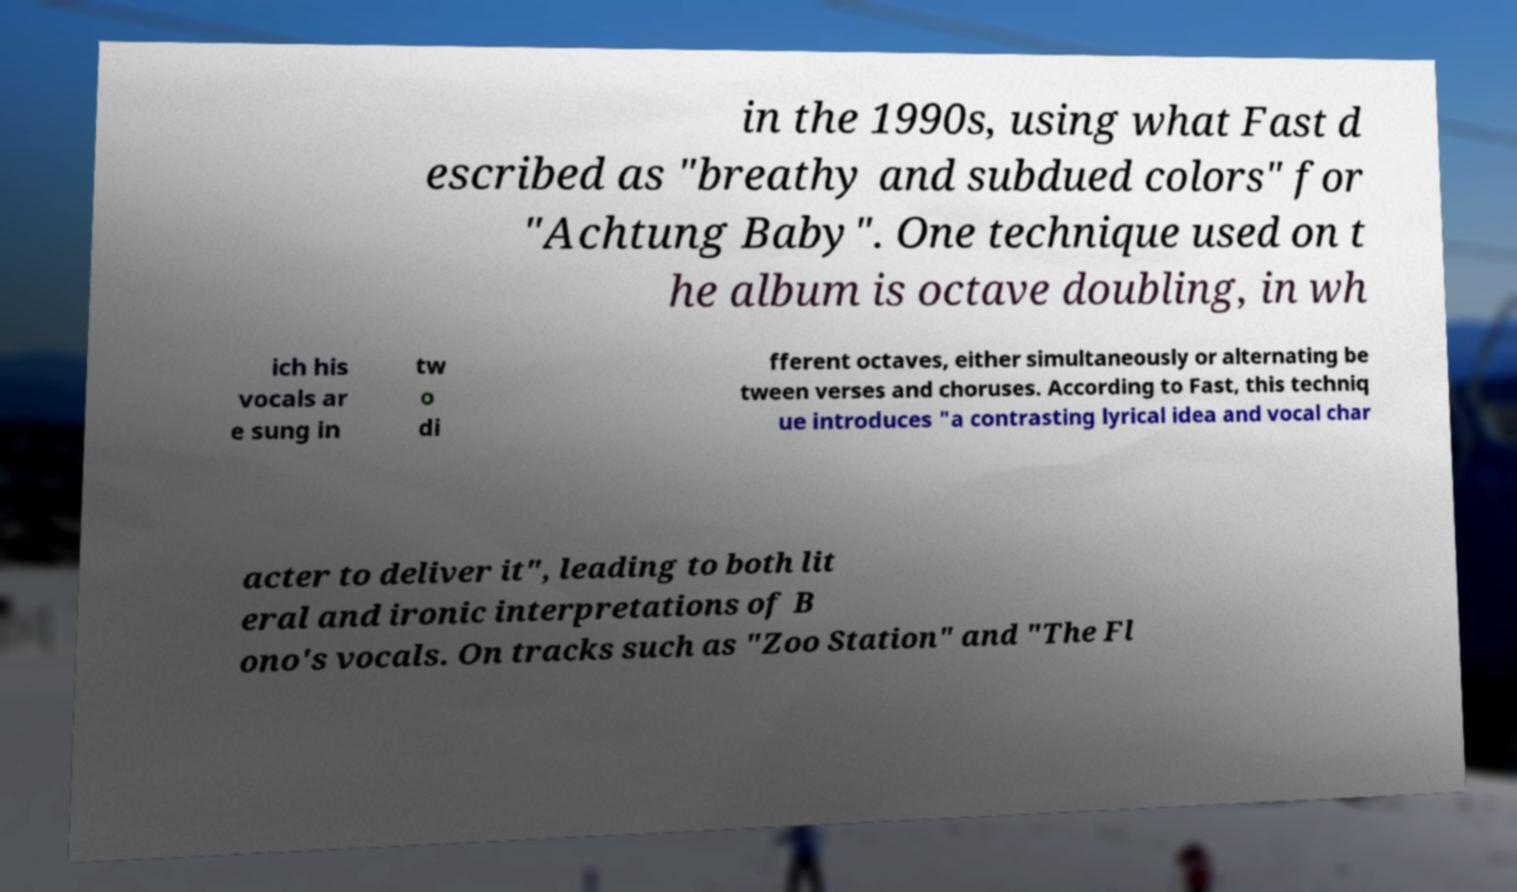What messages or text are displayed in this image? I need them in a readable, typed format. in the 1990s, using what Fast d escribed as "breathy and subdued colors" for "Achtung Baby". One technique used on t he album is octave doubling, in wh ich his vocals ar e sung in tw o di fferent octaves, either simultaneously or alternating be tween verses and choruses. According to Fast, this techniq ue introduces "a contrasting lyrical idea and vocal char acter to deliver it", leading to both lit eral and ironic interpretations of B ono's vocals. On tracks such as "Zoo Station" and "The Fl 